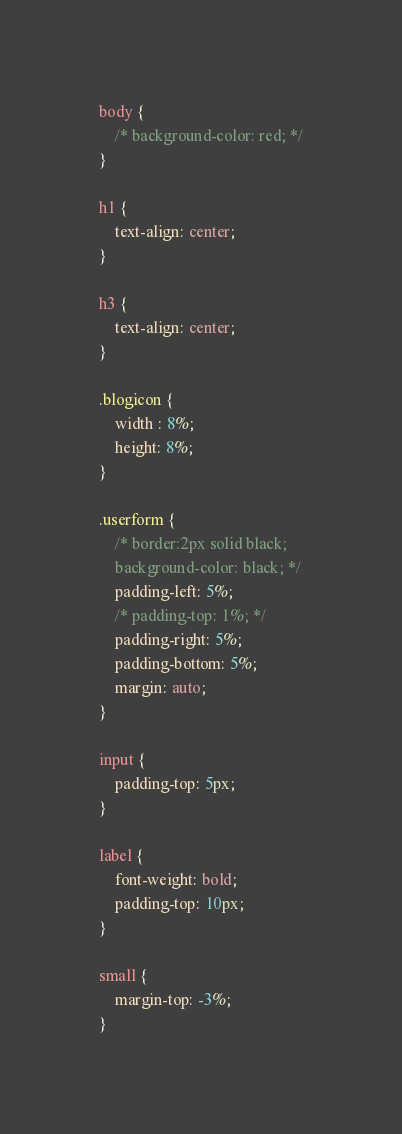<code> <loc_0><loc_0><loc_500><loc_500><_CSS_>body {
    /* background-color: red; */
}

h1 {
    text-align: center;  
}

h3 {
    text-align: center;
}

.blogicon {
    width : 8%;
    height: 8%;
}

.userform {
    /* border:2px solid black;
    background-color: black; */
    padding-left: 5%;
    /* padding-top: 1%; */
    padding-right: 5%;
    padding-bottom: 5%;
    margin: auto;
}

input {
    padding-top: 5px;
}

label {
    font-weight: bold;
    padding-top: 10px;
}

small {
    margin-top: -3%;
}

</code> 